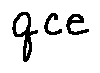Convert formula to latex. <formula><loc_0><loc_0><loc_500><loc_500>q c e</formula> 